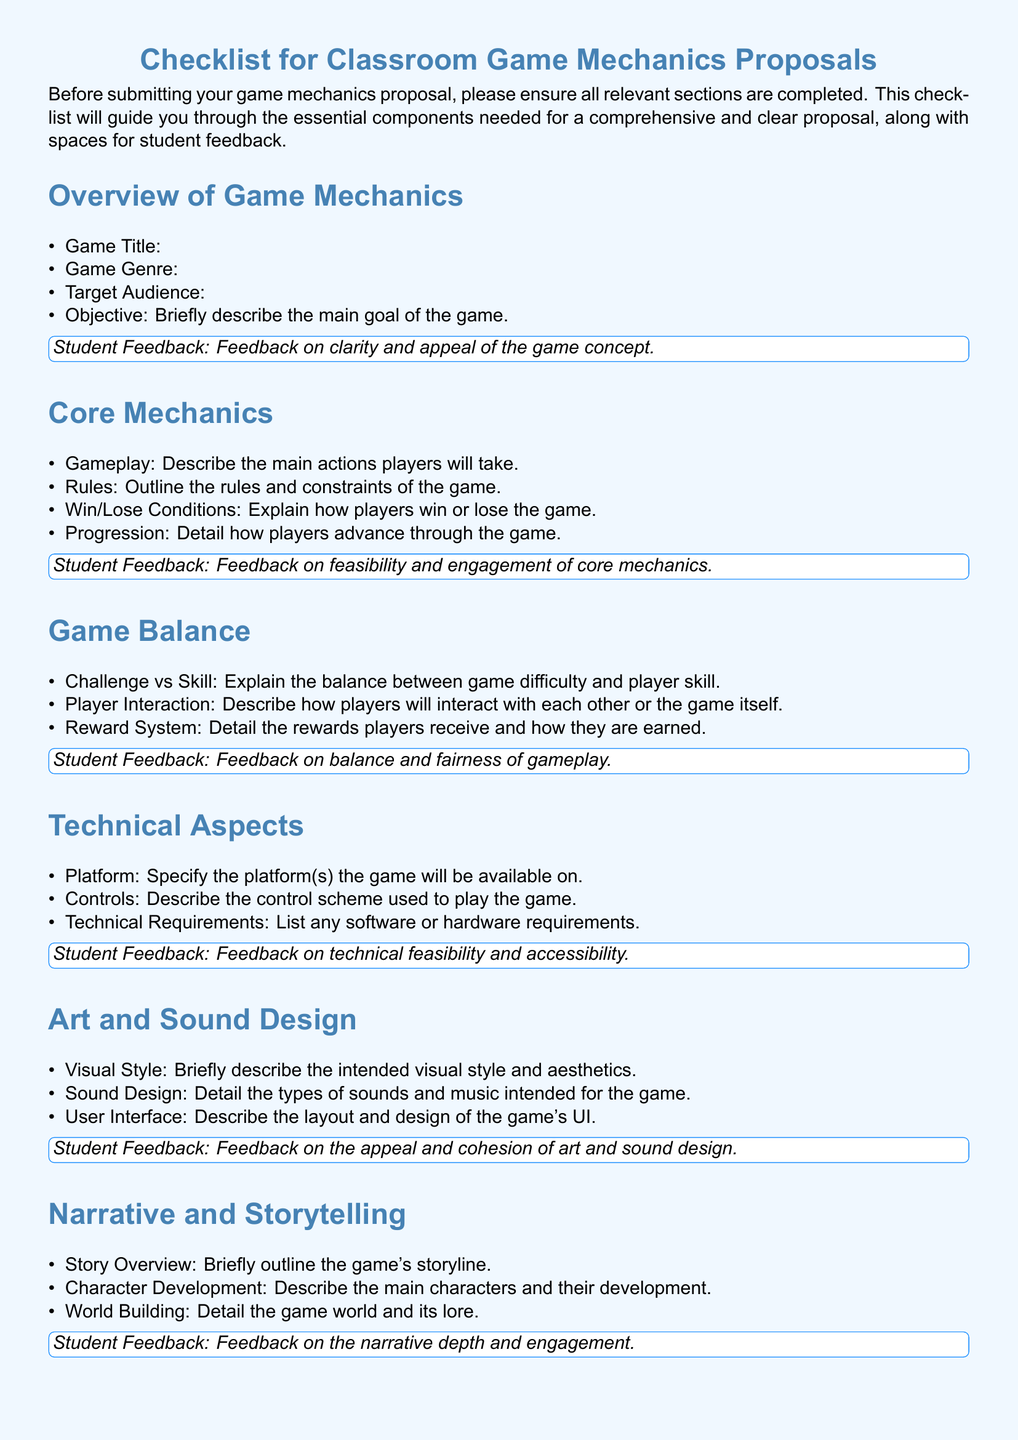What is the title of the checklist? The title of the checklist is presented prominently at the top of the document.
Answer: Checklist for Classroom Game Mechanics Proposals What sections are included in the core mechanics? The core mechanics section includes several specific components that outline gameplay elements.
Answer: Gameplay, Rules, Win/Lose Conditions, Progression What color is used for the feedback box outline? The document specifies a color for the feedback box's frame, which can be identified by its RGB values.
Answer: RGB(30, 144, 255) How many items are there in the Game Balance section? The number of items can be counted from the list presented in that section of the document.
Answer: Three What is the feedback topic for the Technical Aspects section? The feedback box following the Technical Aspects section indicates what aspect should be evaluated.
Answer: Technical feasibility and accessibility What is the main goal of the Playtesting section? This section describes the purpose and process for assessing the game mechanics before finalizing.
Answer: Outline your plan for playtesting the game mechanics What should the Final Review Checklist verify? The checklist in the Final Review section specifies what needs to be confirmed before submission.
Answer: Proposal readiness What is the primary focus of the Art and Sound Design section? This section requires a description of various aesthetic elements of the game, detailing how they contribute to the overall experience.
Answer: Intended visual style and aesthetics What does the Game Balance section discuss regarding Player Interaction? The document highlights how players will engage with each other through the game mechanics outlined.
Answer: How players will interact with each other or the game itself 